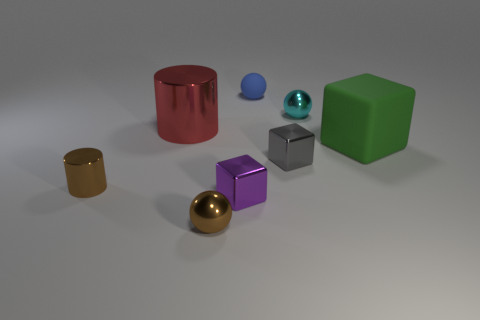There is a small ball that is in front of the red metal cylinder; what material is it?
Provide a short and direct response. Metal. The brown sphere that is the same material as the cyan ball is what size?
Keep it short and to the point. Small. Are there any small objects behind the large green rubber cube?
Provide a succinct answer. Yes. What is the size of the matte object that is the same shape as the tiny cyan metallic object?
Give a very brief answer. Small. Is the color of the small cylinder the same as the ball that is in front of the tiny brown metal cylinder?
Offer a terse response. Yes. Are there fewer tiny purple metallic things than large red rubber objects?
Offer a terse response. No. What number of other things are the same color as the small metallic cylinder?
Your answer should be very brief. 1. How many metallic cylinders are there?
Offer a very short reply. 2. Is the number of gray things right of the tiny gray object less than the number of tiny gray metal cubes?
Your answer should be very brief. Yes. Is the ball that is in front of the gray shiny thing made of the same material as the large block?
Offer a very short reply. No. 